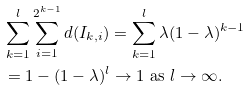<formula> <loc_0><loc_0><loc_500><loc_500>& \sum _ { k = 1 } ^ { l } \sum _ { i = 1 } ^ { 2 ^ { k - 1 } } d ( I _ { k , i } ) = \sum _ { k = 1 } ^ { l } \lambda ( 1 - \lambda ) ^ { k - 1 } \\ & = 1 - ( 1 - \lambda ) ^ { l } \to 1 \ \text {as} \ l \to \infty .</formula> 